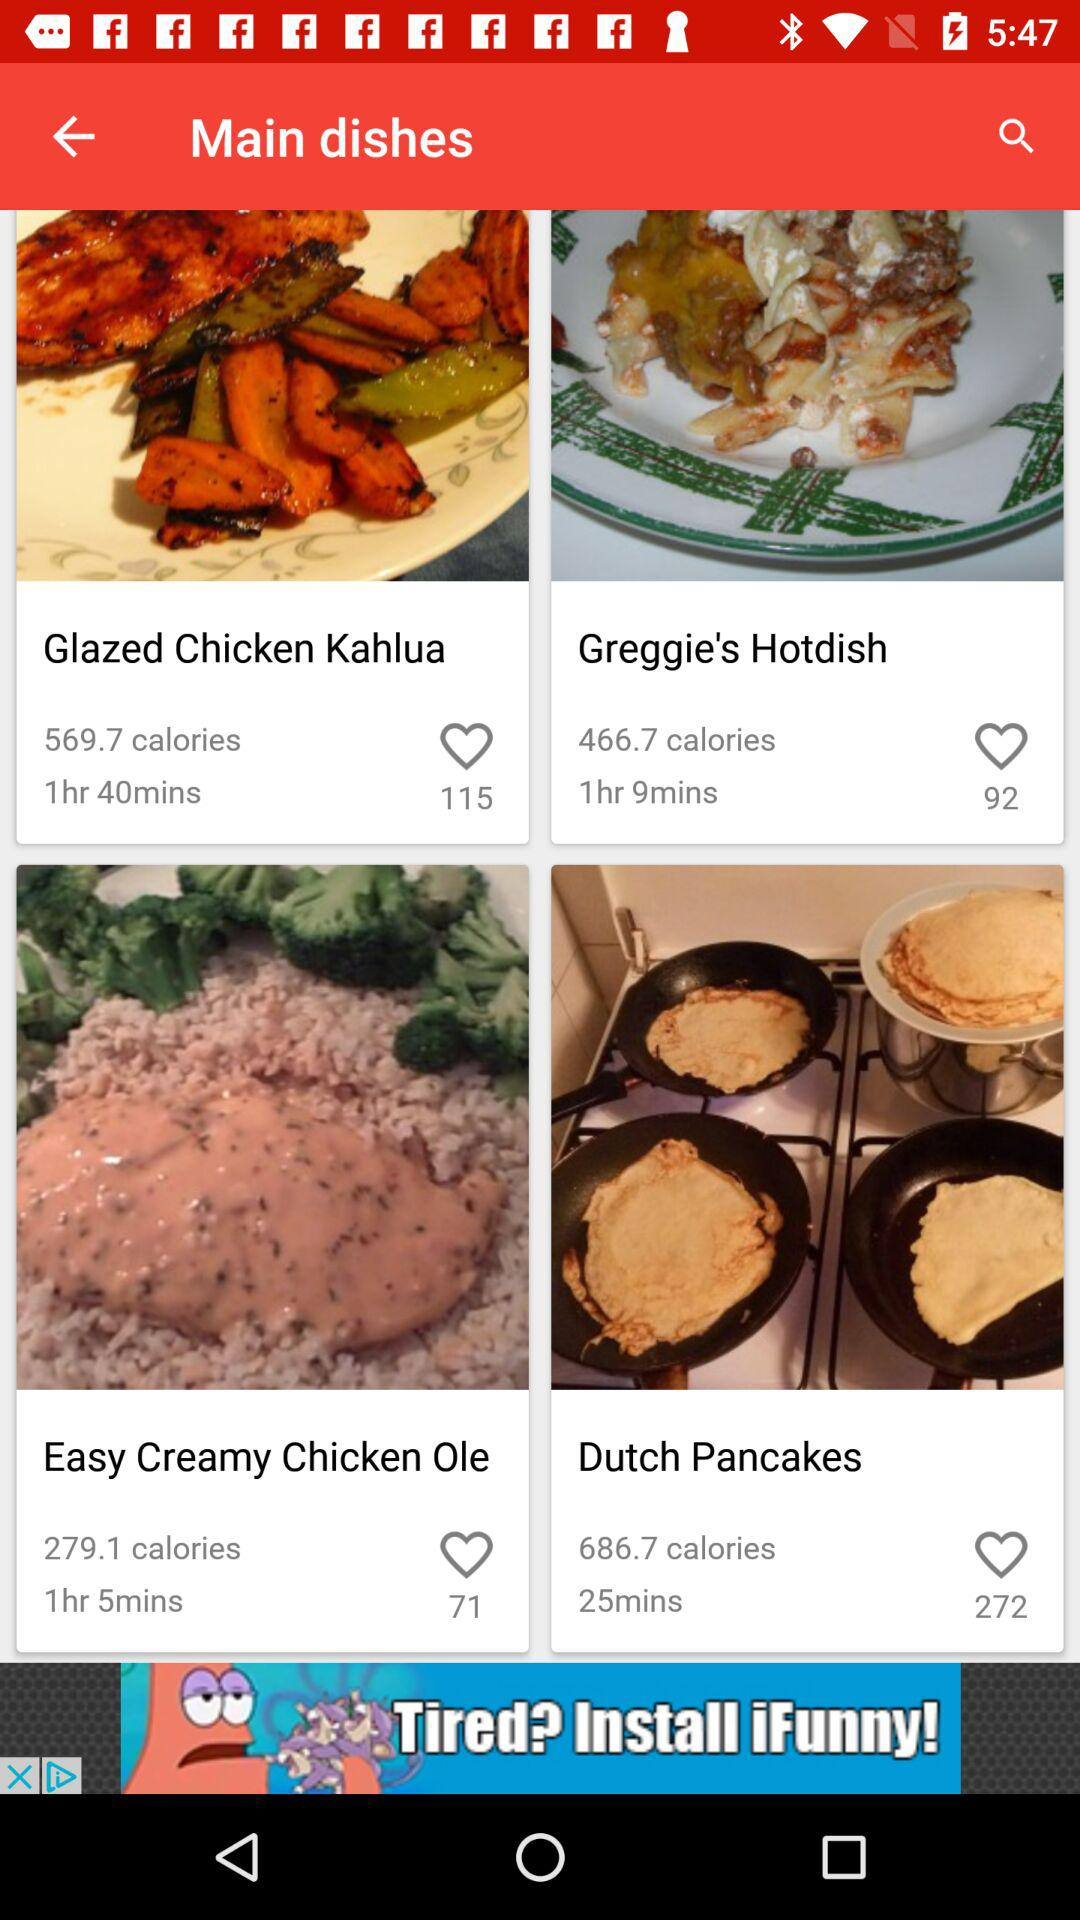What is the preparation time required to make "Greggie's Hotdish"? The preparation time required to make "Greggie's Hotdish" is 1 hour 9 minutes. 